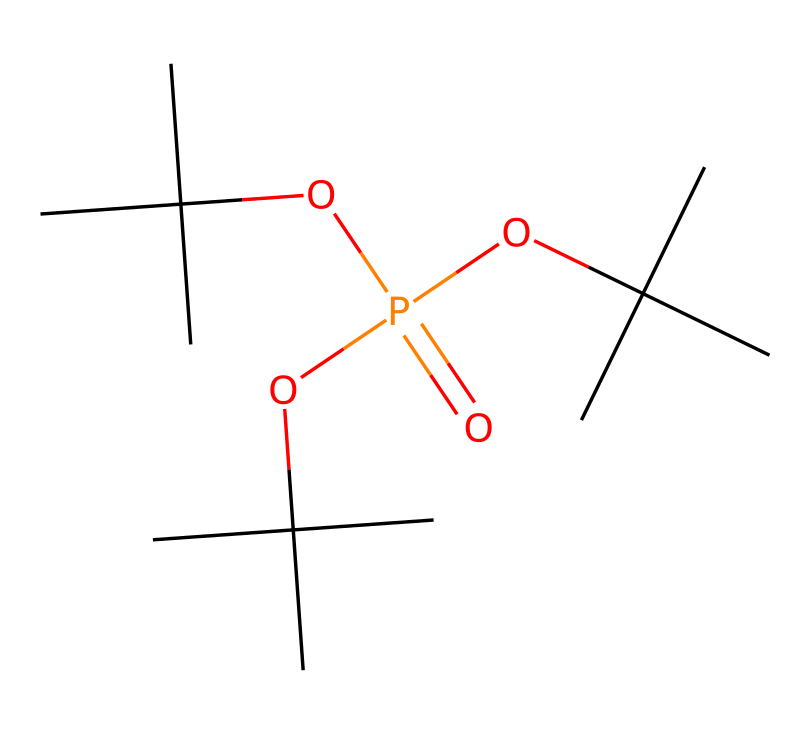what is the main element in this chemical? The SMILES representation indicates the presence of phosphorus (P) as the central atom connected to multiple carbon (C) and oxygen (O) groups.
Answer: phosphorus how many oxygen atoms are in this compound? The structure shows there are four oxygen atoms directly connected to phosphorus and other parts of the molecule, counting them gives us four.
Answer: four what type of chemical is represented by this structure? The presence of phosphorus along with multiple alkyl groups and oxygen indicates that this is a phosphorus-containing flame retardant, classifying it as an organophosphate.
Answer: organophosphate how many carbon atoms are in this molecule? By counting the carbon atoms in the branched alkyl groups surrounding the phosphorus and oxygen atoms, we find there are 12 carbon atoms.
Answer: twelve what functional groups can be identified in this chemical? The chemical contains alkoxy groups (indicated by the presence of OC) attached to the phosphorus atom, representing the functional groups.
Answer: alkoxy groups what property might this compound have that aids in flame retardancy? The presence of phosphorus in the molecule suggests it has phosphorus-based chemistry which often contributes to char formation, a property that retards flame spread.
Answer: char formation how many branches are there in the carbon structure? The structural analysis reveals three identical branched carbon structures attached to the phosphorus, indicating the presence of three branches.
Answer: three 